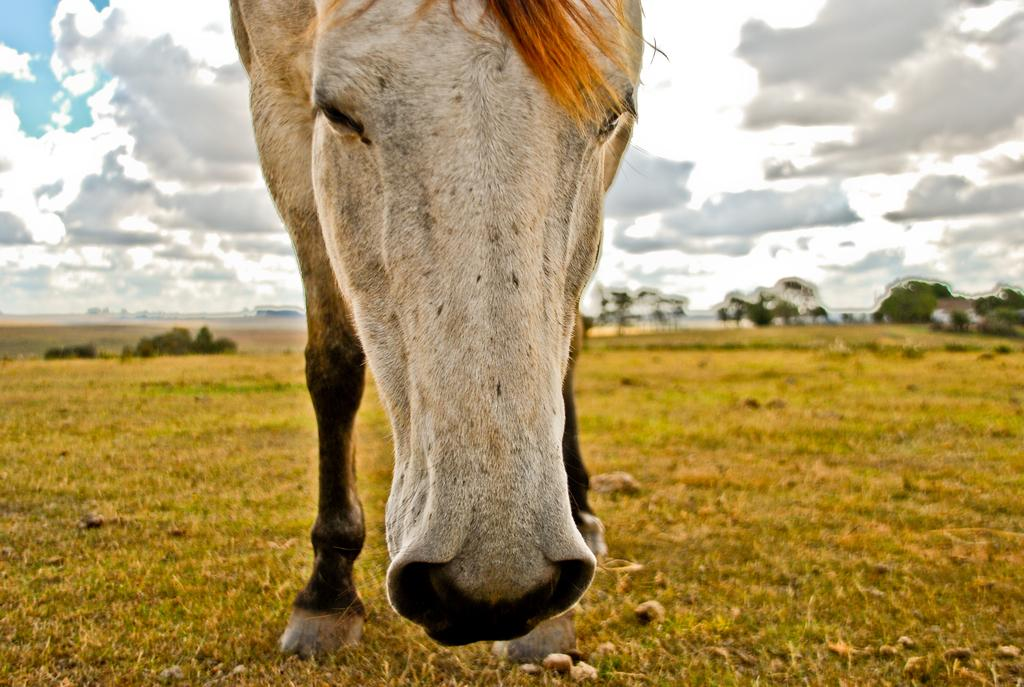What animal can be seen in the image? There is a horse in the image. Where is the horse standing? The horse is standing on the grass. What other objects or elements can be seen in the image? Stones are present in the image. What can be seen in the background of the image? There are trees and the sky visible in the background of the image. What is the condition of the sky in the image? Clouds are present in the sky. How many rabbits can be seen hopping in the front of the image? There are no rabbits present in the image; it features a horse standing on the grass. What type of journey is the horse embarking on in the image? There is no indication of a journey in the image; the horse is simply standing on the grass. 